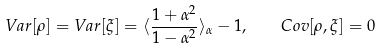<formula> <loc_0><loc_0><loc_500><loc_500>V a r [ \rho ] = V a r [ \xi ] = \langle \frac { 1 + \alpha ^ { 2 } } { 1 - \alpha ^ { 2 } } \rangle _ { \alpha } - 1 , \quad C o v [ \rho , \xi ] = 0</formula> 